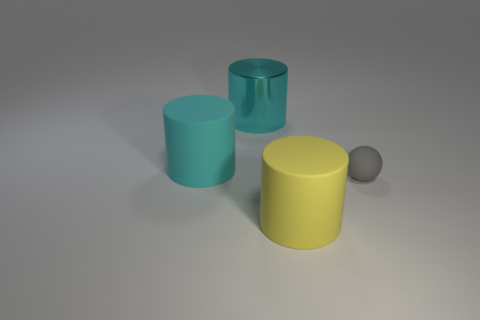If you were to guess, what material do the objects look like they're made of? Based on the visual clues, the cyan cylinders might be made of different types of plastic or metal, suggested by their matte and metallic finishes respectively. The yellow cylinder looks like it could be made from a glossy plastic, and the small gray sphere might be made of rubber, given its dull and non-reflective surface. 